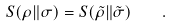Convert formula to latex. <formula><loc_0><loc_0><loc_500><loc_500>S ( \rho \| \sigma ) = S ( \tilde { \rho } \| \tilde { \sigma } ) \quad .</formula> 